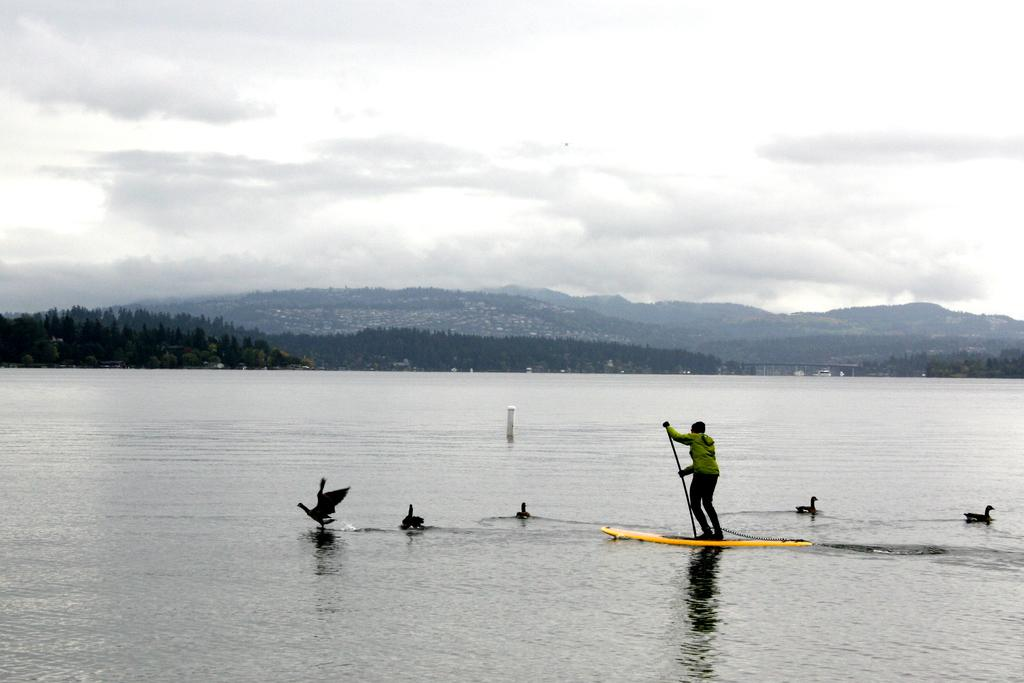What is the man in the image doing? The man is standing on a surfboard in the image. What is the man holding in his hand? The man is holding a stick in his hand. What can be seen in the water in the image? There are ducks in the water. What type of vegetation is visible in the image? There are trees in the image. What type of landscape feature is visible in the image? There are mountains in the image. What is the condition of the sky in the image? The sky is cloudy in the image. What type of wax is being used to shape the surfboard in the image? There is no indication in the image that wax is being used to shape the surfboard, and therefore no such detail can be observed. 